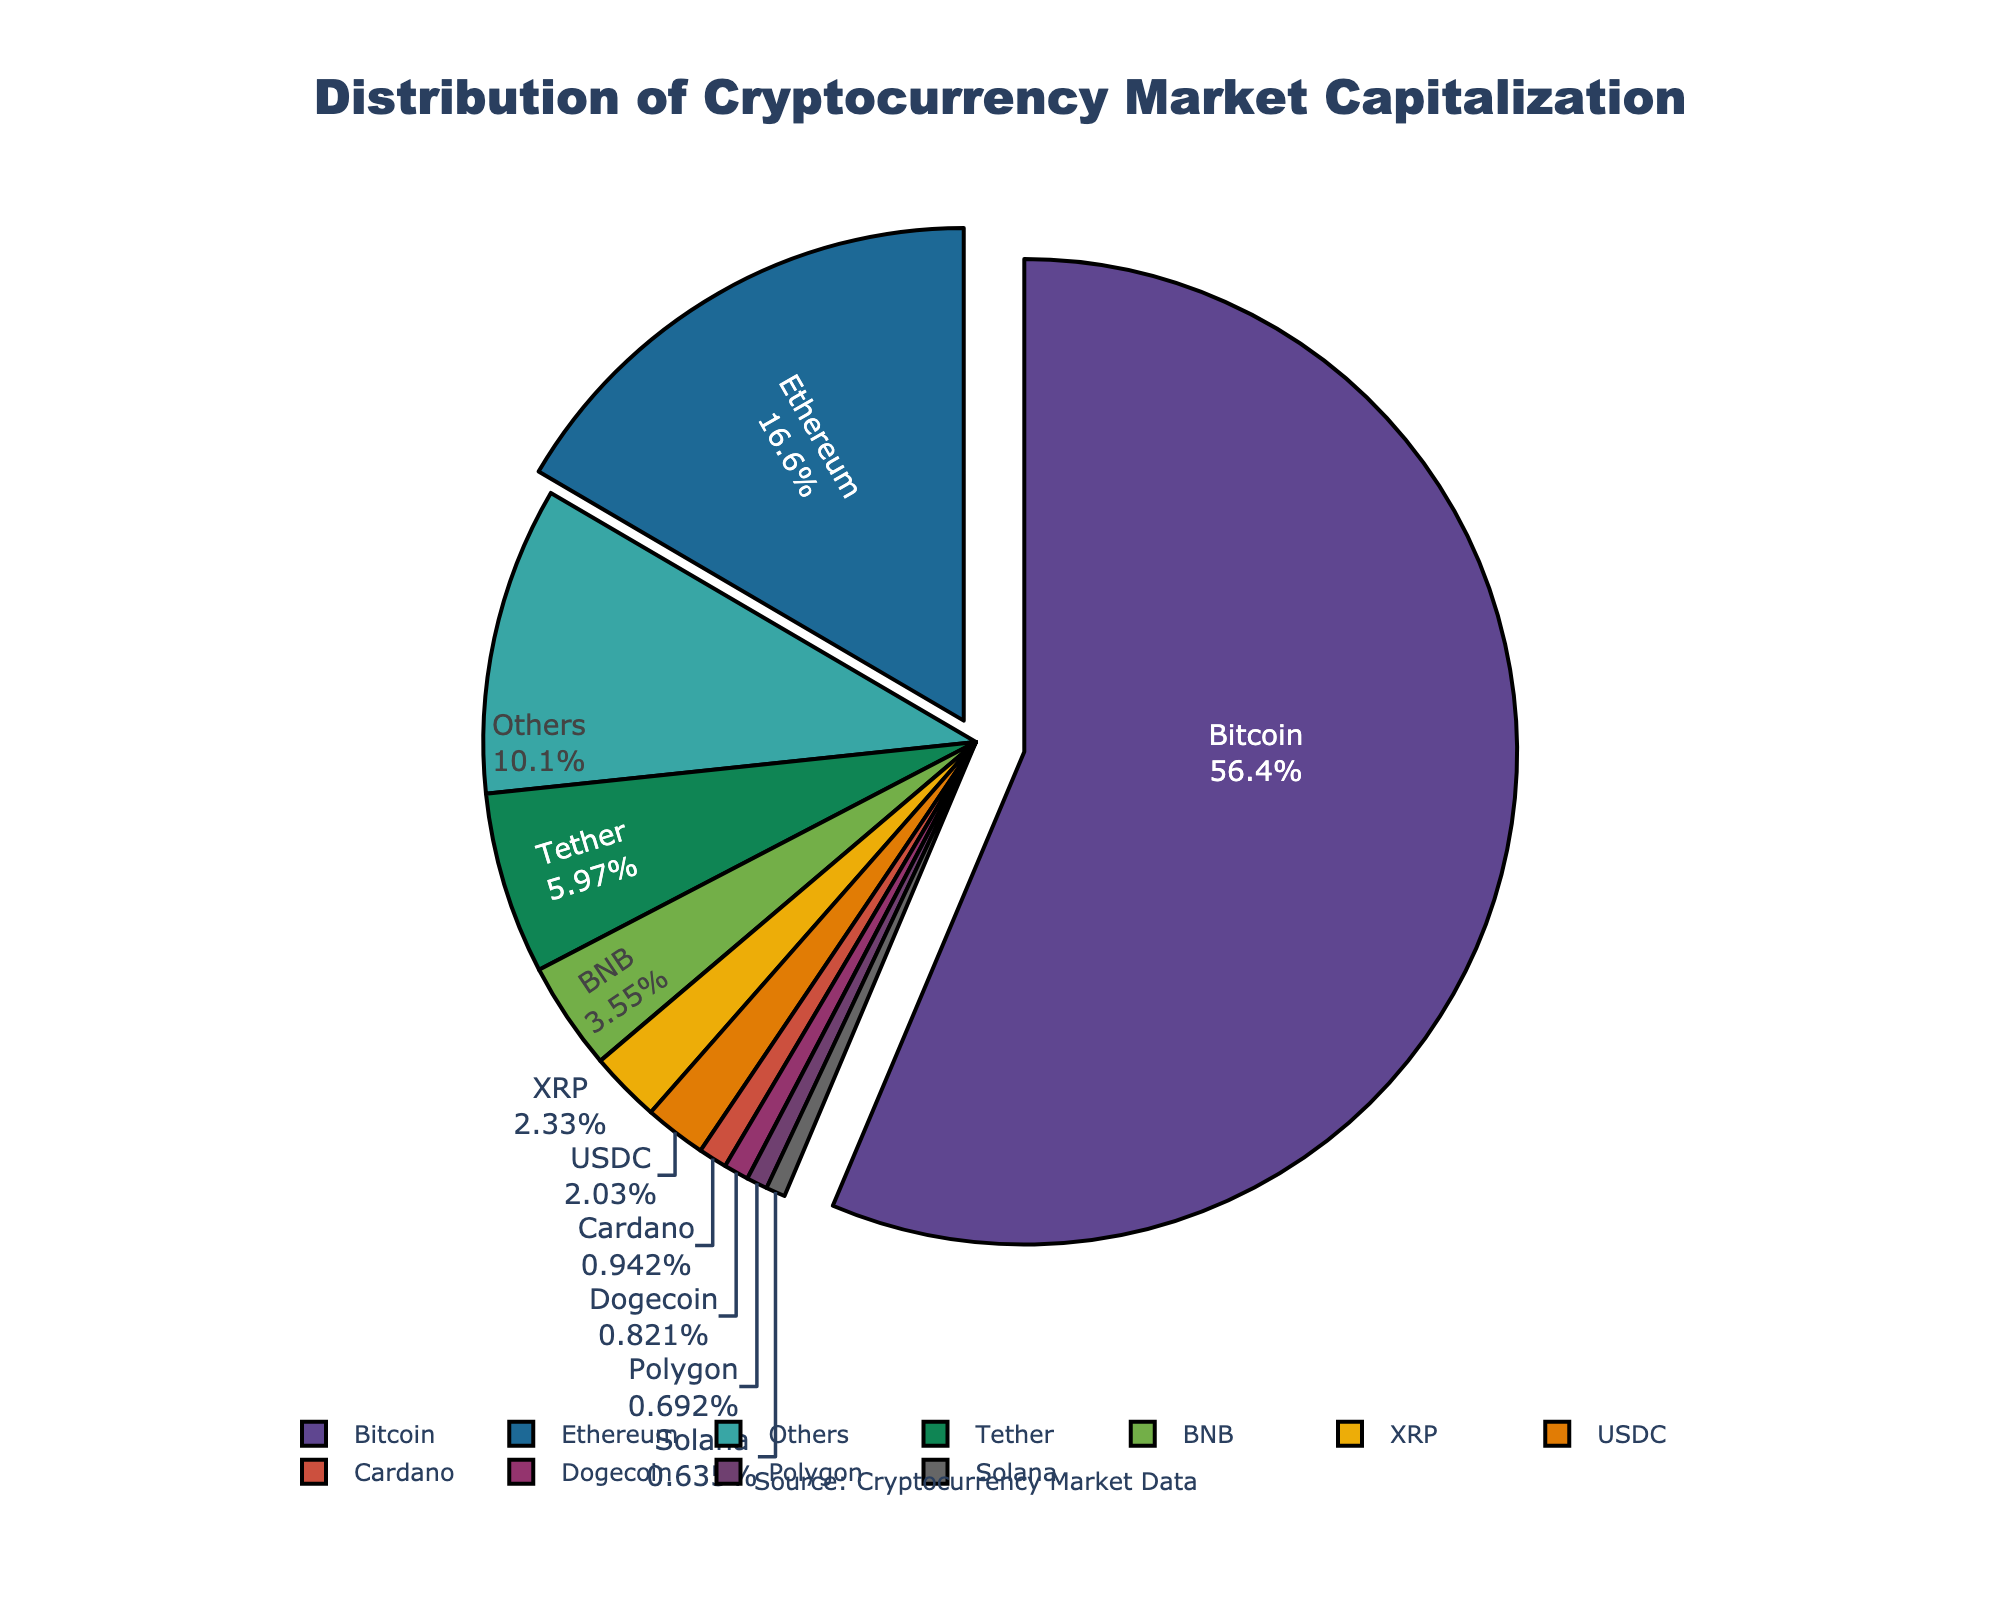what is the percentage share of Bitcoin in the cryptocurrency market capitalization? To find the percentage share of Bitcoin, look at the pie chart and locate the segment labeled "Bitcoin". The percentage should be displayed on the segment.
Answer: 60.2% Which cryptocurrency has the second-largest market capitalization, and what is its percentage share? Find the second-largest segment in the pie chart, which will be the one pulled out slightly next to Bitcoin. The label and percentage share of this segment correspond to the second-largest cryptocurrency.
Answer: Ethereum, 17.7% What is the combined market capitalization of Tether and USDC in USD billions? Find the segments labeled "Tether" and "USDC" in the pie chart. Sum their market capitalizations: 83.7 (Tether) + 28.4 (USDC).
Answer: 112.1 How does the market capitalization of BNB compare to Solana? Locate the segments for BNB and Solana. Compare their sizes visually or look at their percentage shares and market cap values. BNB has a significantly larger market cap.
Answer: BNB is larger than Solana What is the market capitalization difference between XRP and Cardano? Identify the segments for XRP and Cardano. Subtract the market cap of Cardano from XRP: 32.6 (XRP) - 13.2 (Cardano).
Answer: 19.4 billion USD Which cryptocurrencies together constitute more than 25% of the market excluding Bitcoin? Combine the segments other than Bitcoin sequentially until their sum exceeds 25%. Start with Ethereum (17.7%) and add the next largest segment(s). Ethereum and Tether together exceed 25%.
Answer: Ethereum and Tether What is the smallest cryptocurrency in the top 10 by market capitalization, and what is its value? Locate the smallest segment within the top 10 largest segments. The label and market cap value of this segment indicate the answer. The smallest one in the top 10 is Solana.
Answer: Solana, 8.9 billion USD What is the total market capitalization covered by the top 10 cryptocurrencies? Sum the market capitalization values of the top 10 cryptocurrencies listed. Exclude the "Others" segments. Total: 789.5 + 232.1 + 83.7 + 49.8 + 32.6 + 28.4 + 13.2 + 11.5 + 9.7 + 8.9.
Answer: 1,259.4 billion USD 